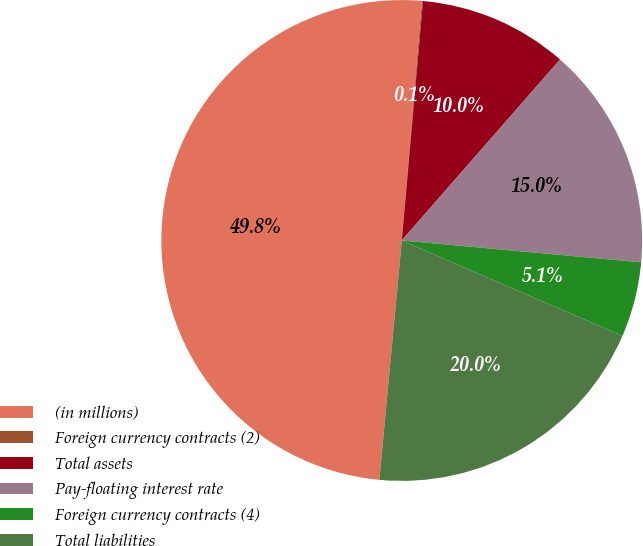Convert chart to OTSL. <chart><loc_0><loc_0><loc_500><loc_500><pie_chart><fcel>(in millions)<fcel>Foreign currency contracts (2)<fcel>Total assets<fcel>Pay-floating interest rate<fcel>Foreign currency contracts (4)<fcel>Total liabilities<nl><fcel>49.85%<fcel>0.07%<fcel>10.03%<fcel>15.01%<fcel>5.05%<fcel>19.99%<nl></chart> 